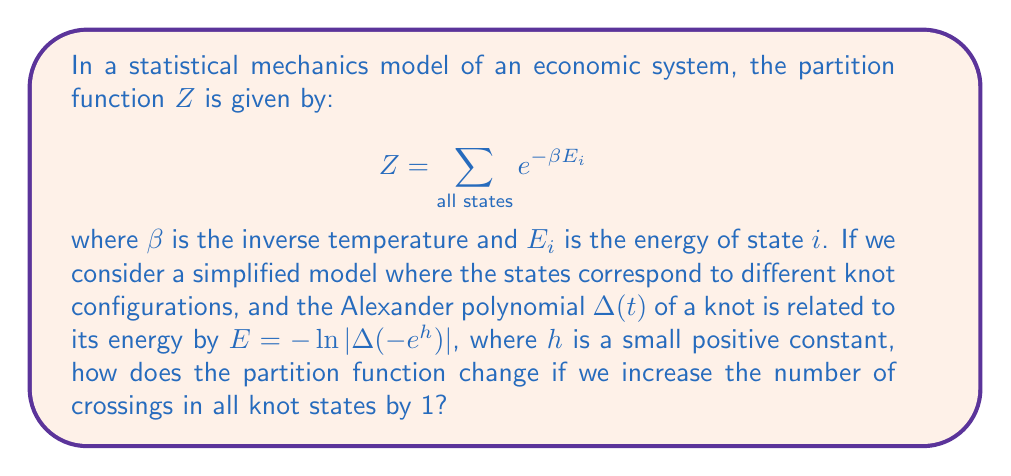Provide a solution to this math problem. Let's approach this step-by-step:

1) First, recall that for a knot with n crossings, the degree of its Alexander polynomial is at most n-1.

2) When we increase the number of crossings by 1 for all knot states, the degree of each Alexander polynomial potentially increases by 1.

3) The Alexander polynomial for a knot with n+1 crossings can be written as:

   $$ \Delta_{n+1}(t) = at\Delta_n(t) + b\Delta_n(t) $$

   where a and b are constants, and $\Delta_n(t)$ is the Alexander polynomial for the original n-crossing knot.

4) Substituting this into our energy equation:

   $$ E_{n+1} = -\ln|\Delta_{n+1}(-e^h)| = -\ln|a(-e^h)\Delta_n(-e^h) + b\Delta_n(-e^h)| $$

5) This can be rewritten as:

   $$ E_{n+1} = -\ln|\Delta_n(-e^h)| - \ln|a(-e^h) + b| = E_n - \ln|a(-e^h) + b| $$

6) The partition function for the new system becomes:

   $$ Z_{new} = \sum_{\text{all states}} e^{-\beta E_{n+1}} = \sum_{\text{all states}} e^{-\beta (E_n - \ln|a(-e^h) + b|)} $$

7) This can be simplified to:

   $$ Z_{new} = |a(-e^h) + b|^\beta \sum_{\text{all states}} e^{-\beta E_n} = |a(-e^h) + b|^\beta Z_{old} $$

8) Therefore, the partition function is scaled by a factor of $|a(-e^h) + b|^\beta$.
Answer: $Z_{new} = |a(-e^h) + b|^\beta Z_{old}$ 